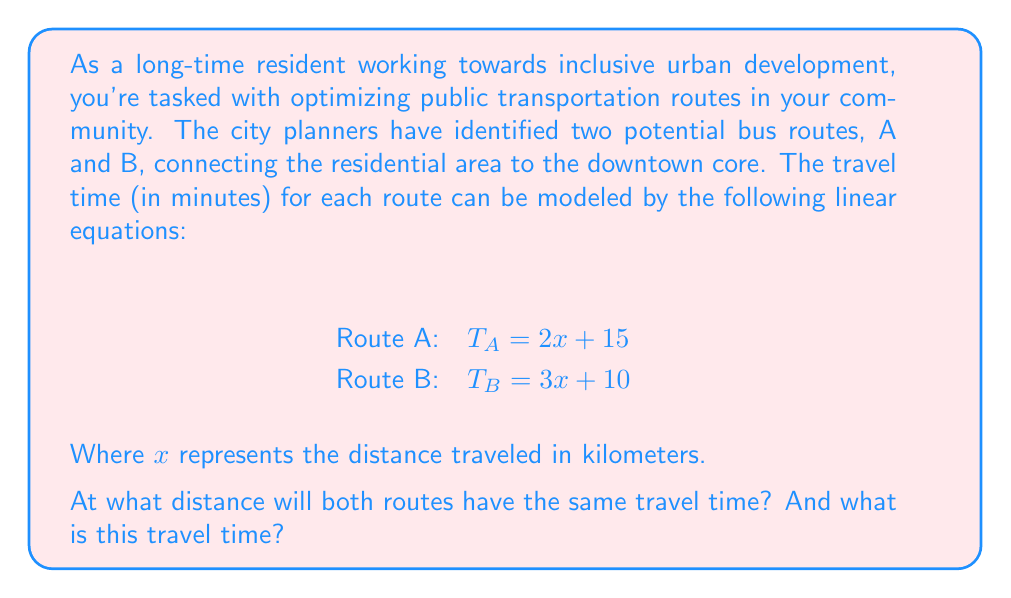Could you help me with this problem? To solve this problem, we need to find the point where the travel times for both routes are equal. This can be done by setting the two equations equal to each other and solving for $x$.

1) Set the equations equal:
   $T_A = T_B$
   $2x + 15 = 3x + 10$

2) Subtract $2x$ from both sides:
   $15 = x + 10$

3) Subtract 10 from both sides:
   $5 = x$

So, the routes will have the same travel time at a distance of 5 kilometers.

4) To find the travel time at this point, we can substitute $x = 5$ into either equation. Let's use Route A:

   $T_A = 2x + 15$
   $T_A = 2(5) + 15$
   $T_A = 10 + 15 = 25$

Therefore, at a distance of 5 kilometers, both routes will have a travel time of 25 minutes.

This information is crucial for urban development as it helps identify the point where the routes are equally efficient, allowing for better planning of bus stops, transfer points, and overall route optimization.
Answer: The routes will have the same travel time at a distance of 5 kilometers, and the travel time at this point is 25 minutes. 